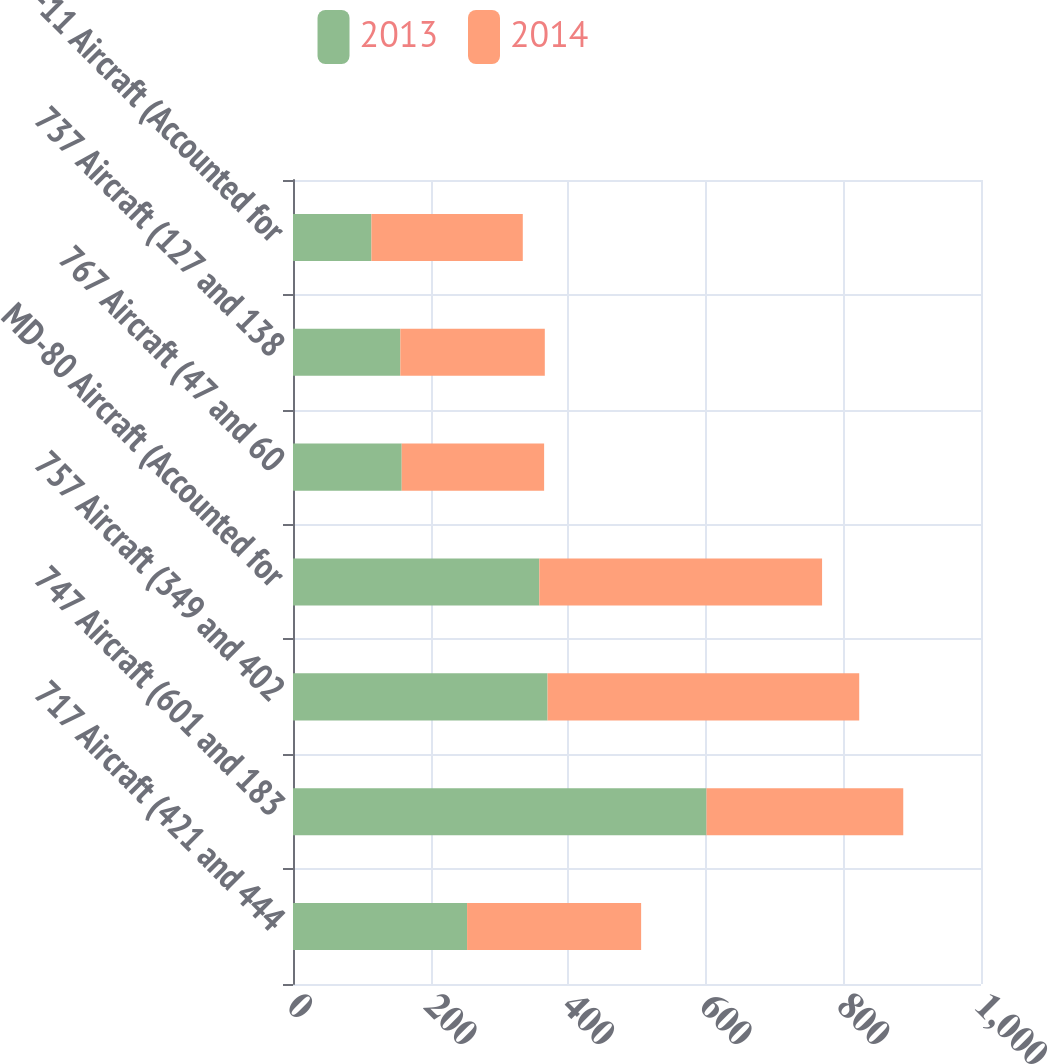Convert chart to OTSL. <chart><loc_0><loc_0><loc_500><loc_500><stacked_bar_chart><ecel><fcel>717 Aircraft (421 and 444<fcel>747 Aircraft (601 and 183<fcel>757 Aircraft (349 and 402<fcel>MD-80 Aircraft (Accounted for<fcel>767 Aircraft (47 and 60<fcel>737 Aircraft (127 and 138<fcel>MD-11 Aircraft (Accounted for<nl><fcel>2013<fcel>253<fcel>601<fcel>370<fcel>358<fcel>158<fcel>156<fcel>114<nl><fcel>2014<fcel>253<fcel>286<fcel>453<fcel>411<fcel>207<fcel>210<fcel>220<nl></chart> 